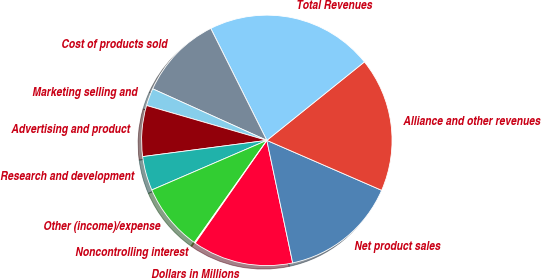<chart> <loc_0><loc_0><loc_500><loc_500><pie_chart><fcel>Dollars in Millions<fcel>Net product sales<fcel>Alliance and other revenues<fcel>Total Revenues<fcel>Cost of products sold<fcel>Marketing selling and<fcel>Advertising and product<fcel>Research and development<fcel>Other (income)/expense<fcel>Noncontrolling interest<nl><fcel>13.01%<fcel>15.16%<fcel>17.31%<fcel>21.61%<fcel>10.86%<fcel>2.26%<fcel>6.56%<fcel>4.41%<fcel>8.71%<fcel>0.11%<nl></chart> 